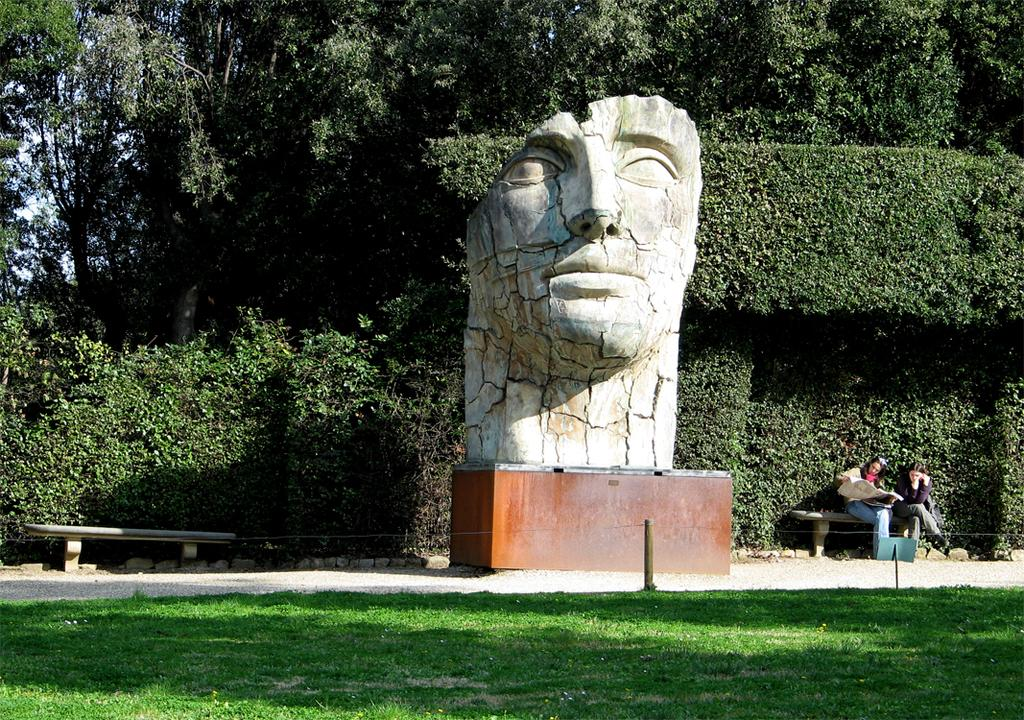What is the main subject in the image? There is a sculpture in the image. What else can be seen in the image besides the sculpture? There is a woman sitting on a bench in the image. What type of natural environment is visible in the image? There is grass and trees visible in the image. What is visible in the background of the image? The sky is visible in the image. What type of cream can be seen on the stick in the image? There is no cream or stick present in the image. What type of chair is the woman sitting on in the image? The woman is sitting on a bench, not a chair, in the image. 